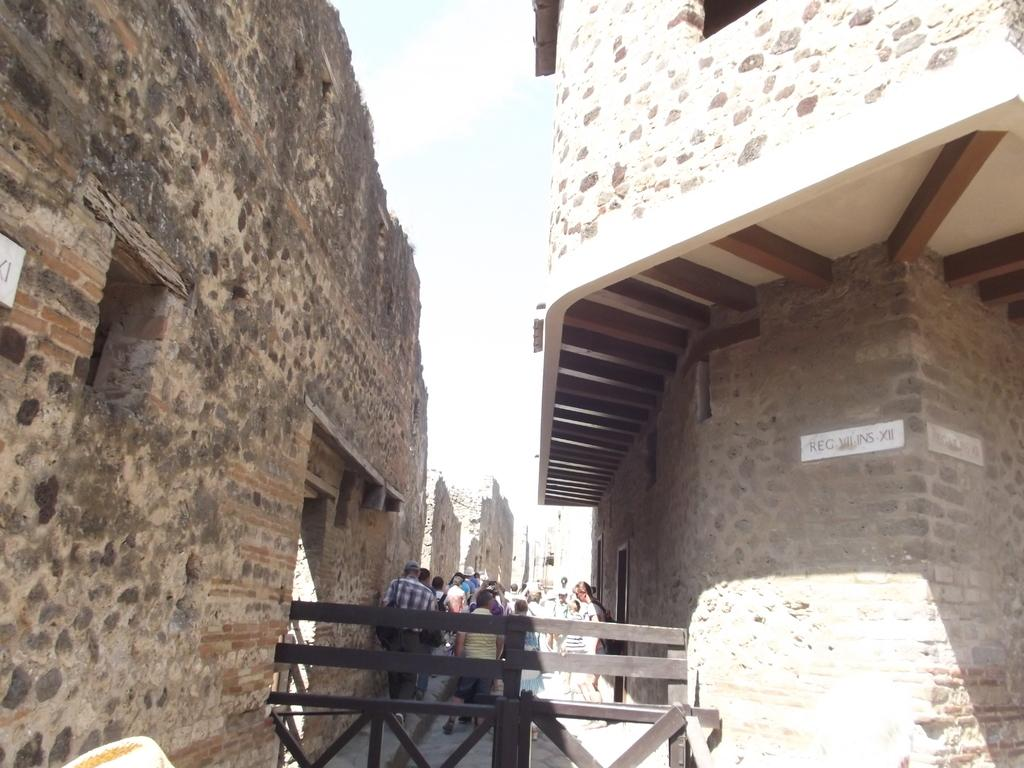What are the people in the image doing? The persons in the image are walking on the path. What is the path surrounded by? The path is behind a fence. What can be seen in the distance in the image? There are buildings in the background of the image. What is the person wearing on their upper body? The person is wearing a shirt. Is there any headgear worn by the person with the shirt? Yes, the person with the shirt is also wearing a cap. Can you see a snake slithering on the path in the image? No, there is no snake present in the image. What type of cloud can be seen in the image? There are no clouds visible in the image, as the sky is not shown. 